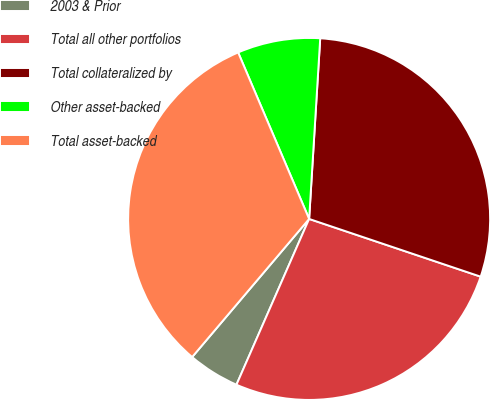Convert chart to OTSL. <chart><loc_0><loc_0><loc_500><loc_500><pie_chart><fcel>2003 & Prior<fcel>Total all other portfolios<fcel>Total collateralized by<fcel>Other asset-backed<fcel>Total asset-backed<nl><fcel>4.61%<fcel>26.41%<fcel>29.19%<fcel>7.39%<fcel>32.4%<nl></chart> 